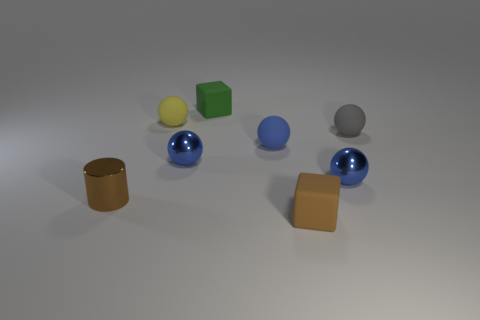What size is the rubber cube behind the tiny matte block in front of the tiny blue metallic thing to the left of the small brown cube?
Ensure brevity in your answer.  Small. Is the number of green rubber blocks right of the brown shiny object the same as the number of tiny brown blocks behind the blue rubber sphere?
Provide a short and direct response. No. There is a gray ball that is the same material as the yellow object; what size is it?
Make the answer very short. Small. The tiny cylinder has what color?
Keep it short and to the point. Brown. What number of things have the same color as the cylinder?
Make the answer very short. 1. There is a gray thing that is the same size as the brown block; what is its material?
Ensure brevity in your answer.  Rubber. Is there a blue metallic ball left of the tiny matte block in front of the tiny yellow matte object?
Make the answer very short. Yes. How many other things are there of the same color as the small cylinder?
Your response must be concise. 1. What is the size of the yellow rubber object?
Ensure brevity in your answer.  Small. Is there a big purple matte cube?
Your response must be concise. No. 